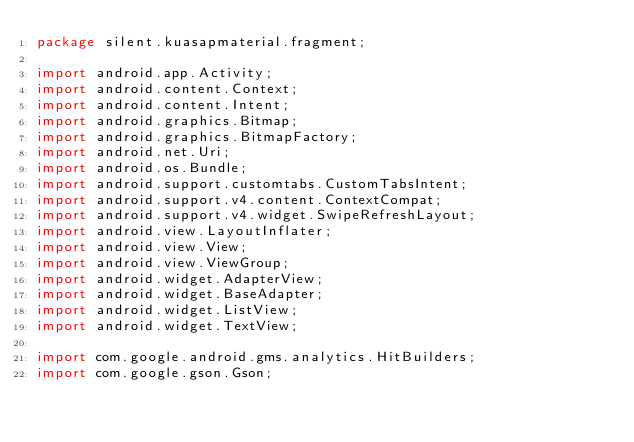Convert code to text. <code><loc_0><loc_0><loc_500><loc_500><_Java_>package silent.kuasapmaterial.fragment;

import android.app.Activity;
import android.content.Context;
import android.content.Intent;
import android.graphics.Bitmap;
import android.graphics.BitmapFactory;
import android.net.Uri;
import android.os.Bundle;
import android.support.customtabs.CustomTabsIntent;
import android.support.v4.content.ContextCompat;
import android.support.v4.widget.SwipeRefreshLayout;
import android.view.LayoutInflater;
import android.view.View;
import android.view.ViewGroup;
import android.widget.AdapterView;
import android.widget.BaseAdapter;
import android.widget.ListView;
import android.widget.TextView;

import com.google.android.gms.analytics.HitBuilders;
import com.google.gson.Gson;</code> 